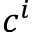Convert formula to latex. <formula><loc_0><loc_0><loc_500><loc_500>c ^ { i }</formula> 